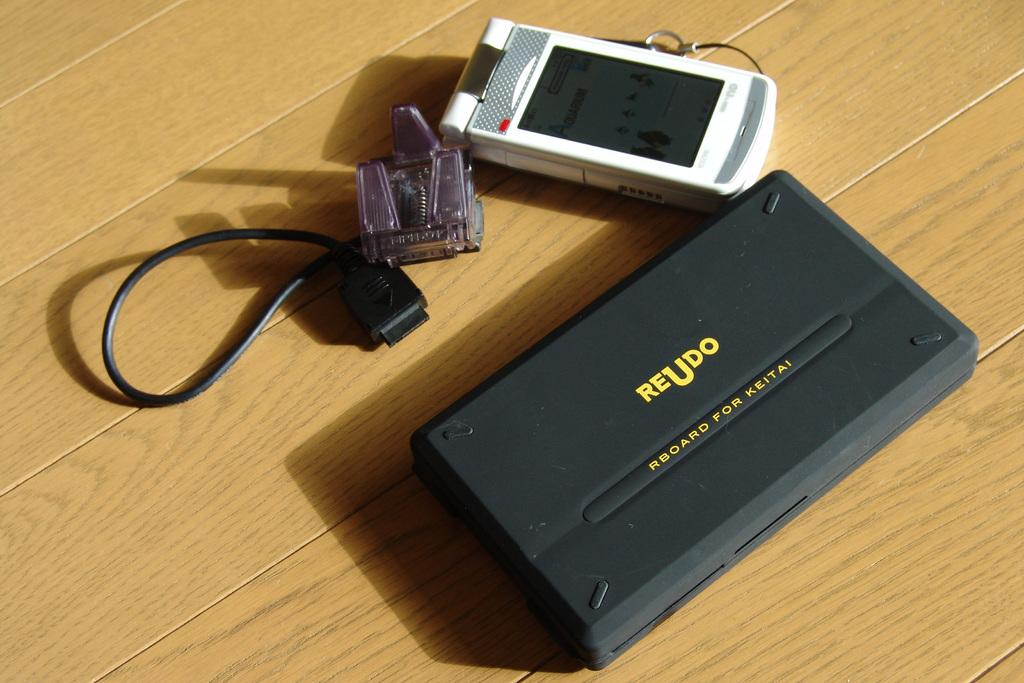<image>
Give a short and clear explanation of the subsequent image. a white cell phone next to a black box reading REUDO 